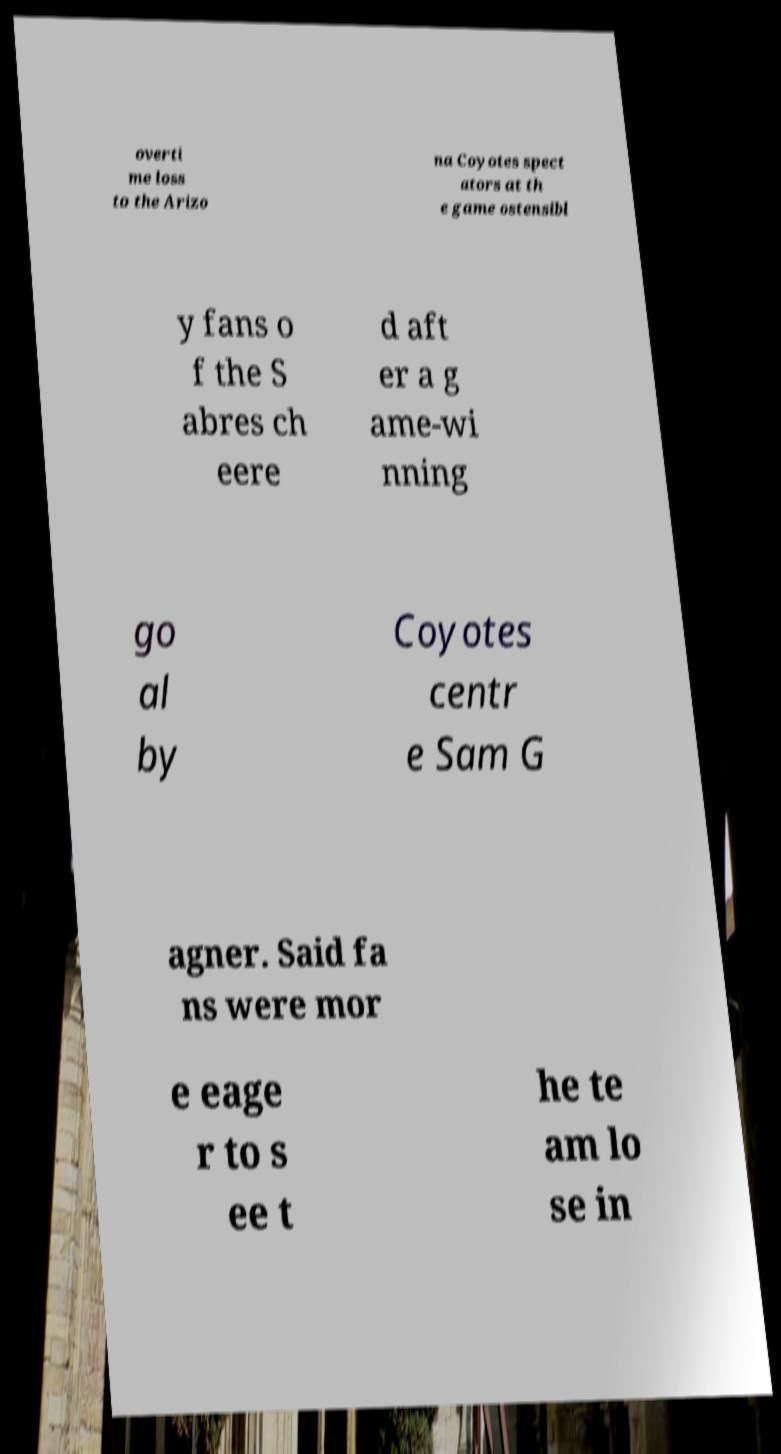Please identify and transcribe the text found in this image. overti me loss to the Arizo na Coyotes spect ators at th e game ostensibl y fans o f the S abres ch eere d aft er a g ame-wi nning go al by Coyotes centr e Sam G agner. Said fa ns were mor e eage r to s ee t he te am lo se in 